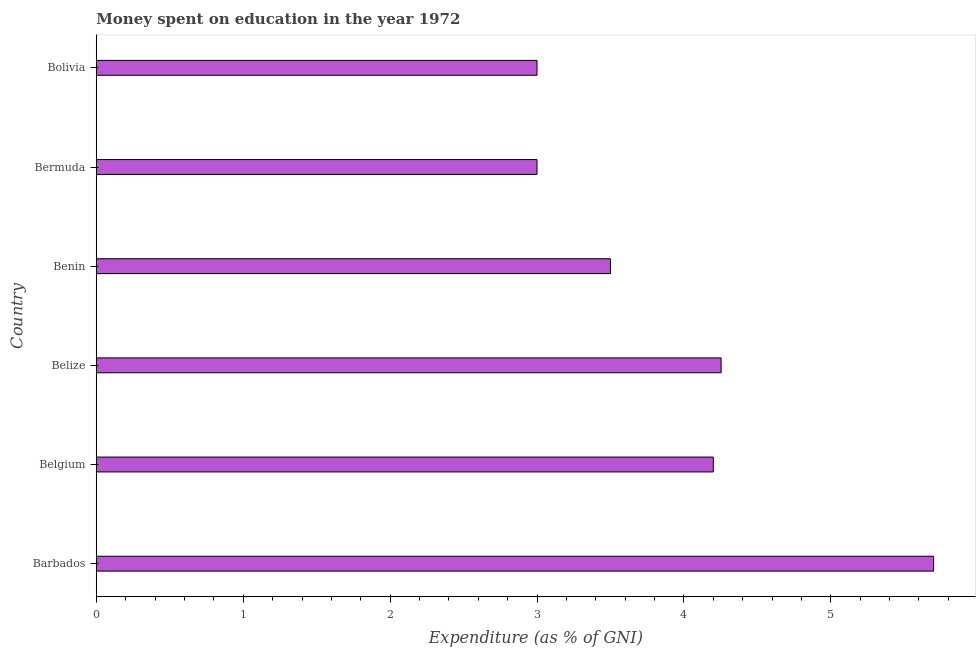What is the title of the graph?
Give a very brief answer. Money spent on education in the year 1972. What is the label or title of the X-axis?
Offer a terse response. Expenditure (as % of GNI). What is the expenditure on education in Bolivia?
Offer a very short reply. 3. In which country was the expenditure on education maximum?
Offer a terse response. Barbados. In which country was the expenditure on education minimum?
Make the answer very short. Bermuda. What is the sum of the expenditure on education?
Offer a very short reply. 23.65. What is the average expenditure on education per country?
Your response must be concise. 3.94. What is the median expenditure on education?
Your answer should be compact. 3.85. In how many countries, is the expenditure on education greater than 3 %?
Provide a short and direct response. 4. What is the ratio of the expenditure on education in Barbados to that in Bermuda?
Provide a succinct answer. 1.9. Is the expenditure on education in Belgium less than that in Benin?
Make the answer very short. No. What is the difference between the highest and the second highest expenditure on education?
Your answer should be compact. 1.45. In how many countries, is the expenditure on education greater than the average expenditure on education taken over all countries?
Make the answer very short. 3. How many bars are there?
Keep it short and to the point. 6. Are all the bars in the graph horizontal?
Ensure brevity in your answer.  Yes. How many countries are there in the graph?
Provide a succinct answer. 6. What is the Expenditure (as % of GNI) of Belgium?
Your response must be concise. 4.2. What is the Expenditure (as % of GNI) in Belize?
Keep it short and to the point. 4.25. What is the difference between the Expenditure (as % of GNI) in Barbados and Belize?
Provide a short and direct response. 1.45. What is the difference between the Expenditure (as % of GNI) in Barbados and Benin?
Offer a very short reply. 2.2. What is the difference between the Expenditure (as % of GNI) in Barbados and Bermuda?
Keep it short and to the point. 2.7. What is the difference between the Expenditure (as % of GNI) in Barbados and Bolivia?
Your answer should be compact. 2.7. What is the difference between the Expenditure (as % of GNI) in Belgium and Belize?
Offer a terse response. -0.05. What is the difference between the Expenditure (as % of GNI) in Belgium and Bolivia?
Provide a succinct answer. 1.2. What is the difference between the Expenditure (as % of GNI) in Belize and Benin?
Your response must be concise. 0.75. What is the difference between the Expenditure (as % of GNI) in Belize and Bermuda?
Your answer should be very brief. 1.25. What is the difference between the Expenditure (as % of GNI) in Belize and Bolivia?
Your response must be concise. 1.25. What is the difference between the Expenditure (as % of GNI) in Benin and Bolivia?
Your answer should be compact. 0.5. What is the difference between the Expenditure (as % of GNI) in Bermuda and Bolivia?
Ensure brevity in your answer.  0. What is the ratio of the Expenditure (as % of GNI) in Barbados to that in Belgium?
Your response must be concise. 1.36. What is the ratio of the Expenditure (as % of GNI) in Barbados to that in Belize?
Your response must be concise. 1.34. What is the ratio of the Expenditure (as % of GNI) in Barbados to that in Benin?
Your response must be concise. 1.63. What is the ratio of the Expenditure (as % of GNI) in Barbados to that in Bolivia?
Your answer should be compact. 1.9. What is the ratio of the Expenditure (as % of GNI) in Belgium to that in Benin?
Provide a succinct answer. 1.2. What is the ratio of the Expenditure (as % of GNI) in Belgium to that in Bolivia?
Offer a very short reply. 1.4. What is the ratio of the Expenditure (as % of GNI) in Belize to that in Benin?
Provide a succinct answer. 1.22. What is the ratio of the Expenditure (as % of GNI) in Belize to that in Bermuda?
Make the answer very short. 1.42. What is the ratio of the Expenditure (as % of GNI) in Belize to that in Bolivia?
Ensure brevity in your answer.  1.42. What is the ratio of the Expenditure (as % of GNI) in Benin to that in Bermuda?
Keep it short and to the point. 1.17. What is the ratio of the Expenditure (as % of GNI) in Benin to that in Bolivia?
Ensure brevity in your answer.  1.17. 